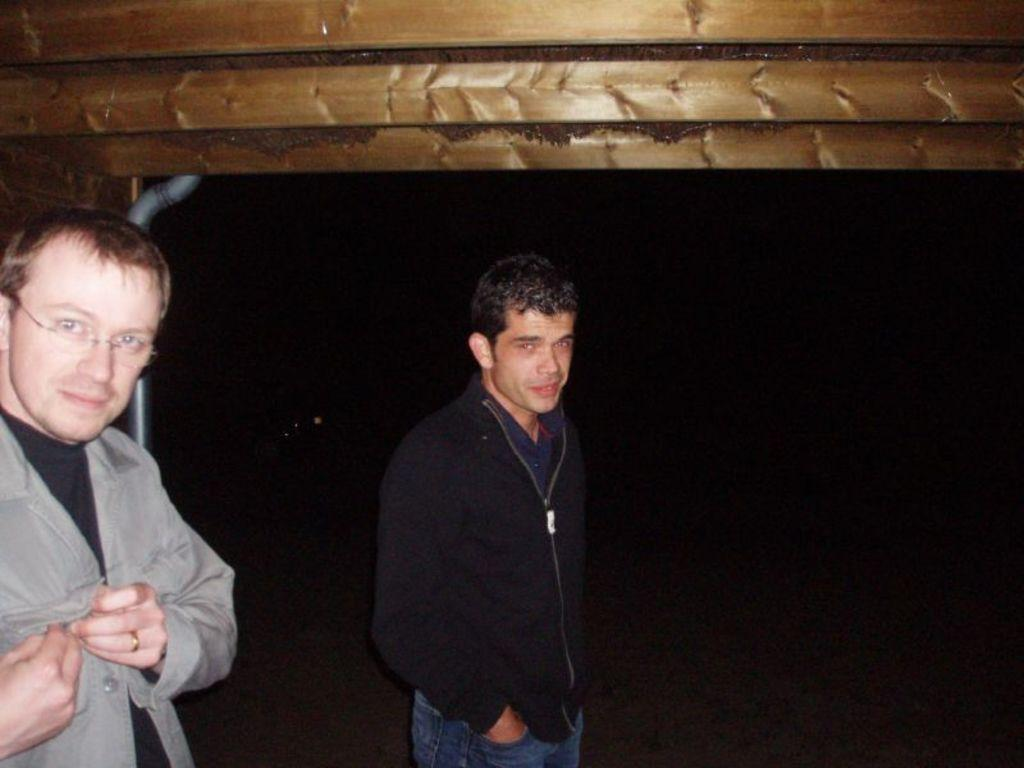How many people are in the image? There are two men in the image. What are the men doing in the image? The men are standing on the ground. What can be seen in the background of the image? There is a pipe and a wooden surface in the background of the image. What is the value of the planes in the image? There are no planes present in the image, so it is not possible to determine their value. 